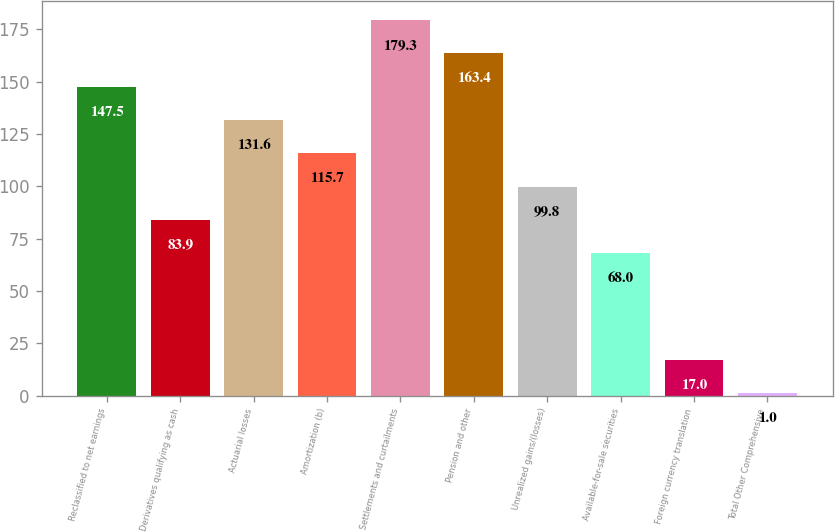Convert chart to OTSL. <chart><loc_0><loc_0><loc_500><loc_500><bar_chart><fcel>Reclassified to net earnings<fcel>Derivatives qualifying as cash<fcel>Actuarial losses<fcel>Amortization (b)<fcel>Settlements and curtailments<fcel>Pension and other<fcel>Unrealized gains/(losses)<fcel>Available-for-sale securities<fcel>Foreign currency translation<fcel>Total Other Comprehensive<nl><fcel>147.5<fcel>83.9<fcel>131.6<fcel>115.7<fcel>179.3<fcel>163.4<fcel>99.8<fcel>68<fcel>17<fcel>1<nl></chart> 